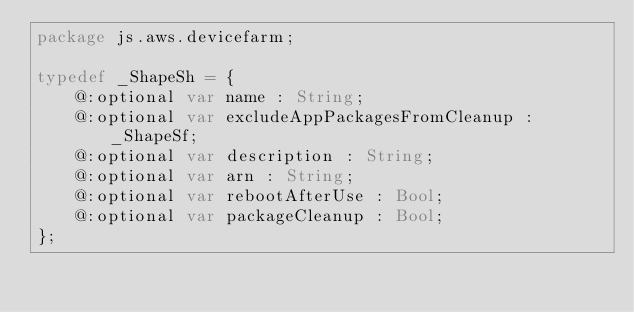Convert code to text. <code><loc_0><loc_0><loc_500><loc_500><_Haxe_>package js.aws.devicefarm;

typedef _ShapeSh = {
    @:optional var name : String;
    @:optional var excludeAppPackagesFromCleanup : _ShapeSf;
    @:optional var description : String;
    @:optional var arn : String;
    @:optional var rebootAfterUse : Bool;
    @:optional var packageCleanup : Bool;
};
</code> 